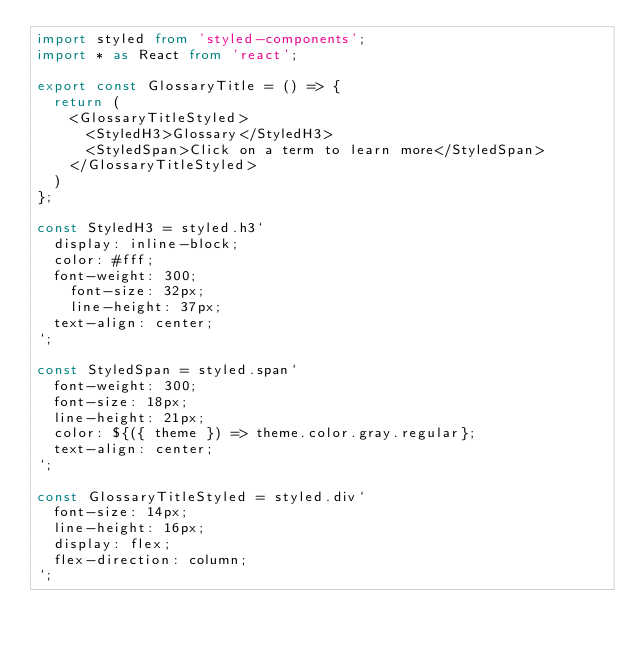<code> <loc_0><loc_0><loc_500><loc_500><_TypeScript_>import styled from 'styled-components';
import * as React from 'react';

export const GlossaryTitle = () => {
	return (
		<GlossaryTitleStyled>
			<StyledH3>Glossary</StyledH3>
			<StyledSpan>Click on a term to learn more</StyledSpan>
		</GlossaryTitleStyled>
	)
};

const StyledH3 = styled.h3`
	display: inline-block;
	color: #fff;
	font-weight: 300;
    font-size: 32px;
    line-height: 37px;
	text-align: center;
`;

const StyledSpan = styled.span`
	font-weight: 300;
	font-size: 18px;
	line-height: 21px;
	color: ${({ theme }) => theme.color.gray.regular};
	text-align: center;
`;

const GlossaryTitleStyled = styled.div`
	font-size: 14px;
	line-height: 16px;
	display: flex;
	flex-direction: column;
`;
</code> 